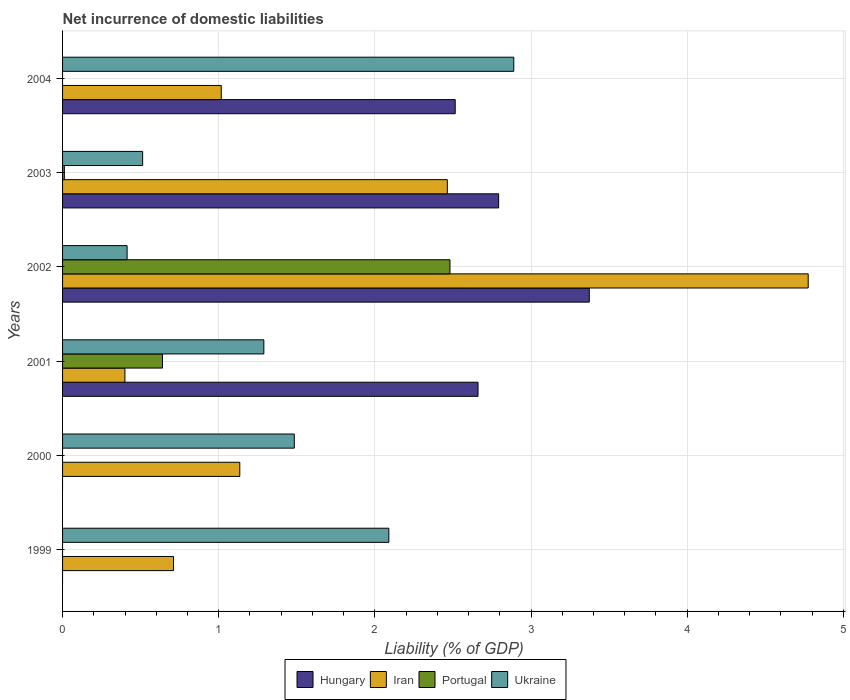How many bars are there on the 1st tick from the bottom?
Offer a terse response. 2. What is the label of the 4th group of bars from the top?
Provide a short and direct response. 2001. What is the net incurrence of domestic liabilities in Ukraine in 2001?
Ensure brevity in your answer.  1.29. Across all years, what is the maximum net incurrence of domestic liabilities in Portugal?
Your answer should be very brief. 2.48. Across all years, what is the minimum net incurrence of domestic liabilities in Ukraine?
Offer a very short reply. 0.41. In which year was the net incurrence of domestic liabilities in Iran maximum?
Ensure brevity in your answer.  2002. What is the total net incurrence of domestic liabilities in Portugal in the graph?
Provide a short and direct response. 3.13. What is the difference between the net incurrence of domestic liabilities in Iran in 2002 and that in 2003?
Provide a succinct answer. 2.31. What is the difference between the net incurrence of domestic liabilities in Hungary in 2001 and the net incurrence of domestic liabilities in Portugal in 2003?
Give a very brief answer. 2.65. What is the average net incurrence of domestic liabilities in Portugal per year?
Your response must be concise. 0.52. In the year 2002, what is the difference between the net incurrence of domestic liabilities in Portugal and net incurrence of domestic liabilities in Iran?
Provide a short and direct response. -2.29. What is the ratio of the net incurrence of domestic liabilities in Portugal in 2002 to that in 2003?
Offer a very short reply. 215.32. Is the net incurrence of domestic liabilities in Iran in 1999 less than that in 2002?
Your answer should be very brief. Yes. Is the difference between the net incurrence of domestic liabilities in Portugal in 2001 and 2002 greater than the difference between the net incurrence of domestic liabilities in Iran in 2001 and 2002?
Your answer should be very brief. Yes. What is the difference between the highest and the second highest net incurrence of domestic liabilities in Portugal?
Offer a very short reply. 1.84. What is the difference between the highest and the lowest net incurrence of domestic liabilities in Ukraine?
Provide a short and direct response. 2.48. Is it the case that in every year, the sum of the net incurrence of domestic liabilities in Hungary and net incurrence of domestic liabilities in Iran is greater than the sum of net incurrence of domestic liabilities in Ukraine and net incurrence of domestic liabilities in Portugal?
Your answer should be very brief. No. Is it the case that in every year, the sum of the net incurrence of domestic liabilities in Iran and net incurrence of domestic liabilities in Portugal is greater than the net incurrence of domestic liabilities in Ukraine?
Provide a succinct answer. No. Are the values on the major ticks of X-axis written in scientific E-notation?
Your answer should be very brief. No. Does the graph contain any zero values?
Give a very brief answer. Yes. Where does the legend appear in the graph?
Ensure brevity in your answer.  Bottom center. How many legend labels are there?
Make the answer very short. 4. What is the title of the graph?
Offer a terse response. Net incurrence of domestic liabilities. What is the label or title of the X-axis?
Keep it short and to the point. Liability (% of GDP). What is the Liability (% of GDP) of Hungary in 1999?
Your answer should be very brief. 0. What is the Liability (% of GDP) of Iran in 1999?
Give a very brief answer. 0.71. What is the Liability (% of GDP) of Portugal in 1999?
Ensure brevity in your answer.  0. What is the Liability (% of GDP) of Ukraine in 1999?
Keep it short and to the point. 2.09. What is the Liability (% of GDP) of Hungary in 2000?
Make the answer very short. 0. What is the Liability (% of GDP) in Iran in 2000?
Give a very brief answer. 1.13. What is the Liability (% of GDP) of Portugal in 2000?
Provide a short and direct response. 0. What is the Liability (% of GDP) of Ukraine in 2000?
Your response must be concise. 1.48. What is the Liability (% of GDP) in Hungary in 2001?
Your answer should be compact. 2.66. What is the Liability (% of GDP) in Iran in 2001?
Make the answer very short. 0.4. What is the Liability (% of GDP) in Portugal in 2001?
Provide a succinct answer. 0.64. What is the Liability (% of GDP) in Ukraine in 2001?
Make the answer very short. 1.29. What is the Liability (% of GDP) of Hungary in 2002?
Give a very brief answer. 3.37. What is the Liability (% of GDP) in Iran in 2002?
Your answer should be compact. 4.78. What is the Liability (% of GDP) of Portugal in 2002?
Give a very brief answer. 2.48. What is the Liability (% of GDP) in Ukraine in 2002?
Ensure brevity in your answer.  0.41. What is the Liability (% of GDP) of Hungary in 2003?
Provide a short and direct response. 2.79. What is the Liability (% of GDP) in Iran in 2003?
Offer a terse response. 2.46. What is the Liability (% of GDP) of Portugal in 2003?
Provide a short and direct response. 0.01. What is the Liability (% of GDP) in Ukraine in 2003?
Provide a succinct answer. 0.51. What is the Liability (% of GDP) of Hungary in 2004?
Ensure brevity in your answer.  2.51. What is the Liability (% of GDP) in Iran in 2004?
Provide a short and direct response. 1.02. What is the Liability (% of GDP) of Portugal in 2004?
Keep it short and to the point. 0. What is the Liability (% of GDP) of Ukraine in 2004?
Your response must be concise. 2.89. Across all years, what is the maximum Liability (% of GDP) of Hungary?
Your answer should be compact. 3.37. Across all years, what is the maximum Liability (% of GDP) in Iran?
Your answer should be very brief. 4.78. Across all years, what is the maximum Liability (% of GDP) of Portugal?
Your answer should be very brief. 2.48. Across all years, what is the maximum Liability (% of GDP) in Ukraine?
Give a very brief answer. 2.89. Across all years, what is the minimum Liability (% of GDP) of Iran?
Offer a terse response. 0.4. Across all years, what is the minimum Liability (% of GDP) of Ukraine?
Offer a very short reply. 0.41. What is the total Liability (% of GDP) in Hungary in the graph?
Your answer should be compact. 11.34. What is the total Liability (% of GDP) in Iran in the graph?
Offer a very short reply. 10.5. What is the total Liability (% of GDP) of Portugal in the graph?
Provide a short and direct response. 3.13. What is the total Liability (% of GDP) in Ukraine in the graph?
Offer a very short reply. 8.68. What is the difference between the Liability (% of GDP) in Iran in 1999 and that in 2000?
Provide a succinct answer. -0.42. What is the difference between the Liability (% of GDP) of Ukraine in 1999 and that in 2000?
Your answer should be very brief. 0.61. What is the difference between the Liability (% of GDP) in Iran in 1999 and that in 2001?
Ensure brevity in your answer.  0.31. What is the difference between the Liability (% of GDP) in Ukraine in 1999 and that in 2001?
Offer a very short reply. 0.8. What is the difference between the Liability (% of GDP) of Iran in 1999 and that in 2002?
Offer a terse response. -4.06. What is the difference between the Liability (% of GDP) of Ukraine in 1999 and that in 2002?
Your answer should be very brief. 1.68. What is the difference between the Liability (% of GDP) in Iran in 1999 and that in 2003?
Make the answer very short. -1.75. What is the difference between the Liability (% of GDP) of Ukraine in 1999 and that in 2003?
Make the answer very short. 1.58. What is the difference between the Liability (% of GDP) in Iran in 1999 and that in 2004?
Offer a terse response. -0.31. What is the difference between the Liability (% of GDP) of Iran in 2000 and that in 2001?
Keep it short and to the point. 0.74. What is the difference between the Liability (% of GDP) of Ukraine in 2000 and that in 2001?
Keep it short and to the point. 0.2. What is the difference between the Liability (% of GDP) of Iran in 2000 and that in 2002?
Provide a succinct answer. -3.64. What is the difference between the Liability (% of GDP) of Ukraine in 2000 and that in 2002?
Your answer should be compact. 1.07. What is the difference between the Liability (% of GDP) in Iran in 2000 and that in 2003?
Provide a short and direct response. -1.33. What is the difference between the Liability (% of GDP) of Ukraine in 2000 and that in 2003?
Offer a terse response. 0.97. What is the difference between the Liability (% of GDP) in Iran in 2000 and that in 2004?
Make the answer very short. 0.12. What is the difference between the Liability (% of GDP) of Ukraine in 2000 and that in 2004?
Offer a very short reply. -1.41. What is the difference between the Liability (% of GDP) of Hungary in 2001 and that in 2002?
Provide a short and direct response. -0.71. What is the difference between the Liability (% of GDP) of Iran in 2001 and that in 2002?
Your answer should be compact. -4.38. What is the difference between the Liability (% of GDP) of Portugal in 2001 and that in 2002?
Your answer should be compact. -1.84. What is the difference between the Liability (% of GDP) in Ukraine in 2001 and that in 2002?
Ensure brevity in your answer.  0.88. What is the difference between the Liability (% of GDP) in Hungary in 2001 and that in 2003?
Provide a short and direct response. -0.13. What is the difference between the Liability (% of GDP) of Iran in 2001 and that in 2003?
Offer a terse response. -2.06. What is the difference between the Liability (% of GDP) in Portugal in 2001 and that in 2003?
Your answer should be very brief. 0.63. What is the difference between the Liability (% of GDP) of Ukraine in 2001 and that in 2003?
Your response must be concise. 0.78. What is the difference between the Liability (% of GDP) of Hungary in 2001 and that in 2004?
Provide a succinct answer. 0.15. What is the difference between the Liability (% of GDP) of Iran in 2001 and that in 2004?
Your response must be concise. -0.62. What is the difference between the Liability (% of GDP) in Ukraine in 2001 and that in 2004?
Offer a very short reply. -1.6. What is the difference between the Liability (% of GDP) of Hungary in 2002 and that in 2003?
Offer a terse response. 0.58. What is the difference between the Liability (% of GDP) of Iran in 2002 and that in 2003?
Your answer should be compact. 2.31. What is the difference between the Liability (% of GDP) in Portugal in 2002 and that in 2003?
Keep it short and to the point. 2.47. What is the difference between the Liability (% of GDP) in Ukraine in 2002 and that in 2003?
Make the answer very short. -0.1. What is the difference between the Liability (% of GDP) of Hungary in 2002 and that in 2004?
Give a very brief answer. 0.86. What is the difference between the Liability (% of GDP) in Iran in 2002 and that in 2004?
Offer a very short reply. 3.76. What is the difference between the Liability (% of GDP) of Ukraine in 2002 and that in 2004?
Your response must be concise. -2.48. What is the difference between the Liability (% of GDP) in Hungary in 2003 and that in 2004?
Ensure brevity in your answer.  0.28. What is the difference between the Liability (% of GDP) of Iran in 2003 and that in 2004?
Ensure brevity in your answer.  1.45. What is the difference between the Liability (% of GDP) of Ukraine in 2003 and that in 2004?
Offer a terse response. -2.38. What is the difference between the Liability (% of GDP) in Iran in 1999 and the Liability (% of GDP) in Ukraine in 2000?
Provide a short and direct response. -0.77. What is the difference between the Liability (% of GDP) in Iran in 1999 and the Liability (% of GDP) in Portugal in 2001?
Your answer should be compact. 0.07. What is the difference between the Liability (% of GDP) of Iran in 1999 and the Liability (% of GDP) of Ukraine in 2001?
Give a very brief answer. -0.58. What is the difference between the Liability (% of GDP) in Iran in 1999 and the Liability (% of GDP) in Portugal in 2002?
Give a very brief answer. -1.77. What is the difference between the Liability (% of GDP) of Iran in 1999 and the Liability (% of GDP) of Ukraine in 2002?
Provide a short and direct response. 0.3. What is the difference between the Liability (% of GDP) in Iran in 1999 and the Liability (% of GDP) in Portugal in 2003?
Provide a short and direct response. 0.7. What is the difference between the Liability (% of GDP) in Iran in 1999 and the Liability (% of GDP) in Ukraine in 2003?
Your answer should be compact. 0.2. What is the difference between the Liability (% of GDP) of Iran in 1999 and the Liability (% of GDP) of Ukraine in 2004?
Your response must be concise. -2.18. What is the difference between the Liability (% of GDP) in Iran in 2000 and the Liability (% of GDP) in Portugal in 2001?
Give a very brief answer. 0.5. What is the difference between the Liability (% of GDP) of Iran in 2000 and the Liability (% of GDP) of Ukraine in 2001?
Provide a short and direct response. -0.15. What is the difference between the Liability (% of GDP) of Iran in 2000 and the Liability (% of GDP) of Portugal in 2002?
Ensure brevity in your answer.  -1.35. What is the difference between the Liability (% of GDP) of Iran in 2000 and the Liability (% of GDP) of Ukraine in 2002?
Make the answer very short. 0.72. What is the difference between the Liability (% of GDP) of Iran in 2000 and the Liability (% of GDP) of Portugal in 2003?
Give a very brief answer. 1.12. What is the difference between the Liability (% of GDP) in Iran in 2000 and the Liability (% of GDP) in Ukraine in 2003?
Your response must be concise. 0.62. What is the difference between the Liability (% of GDP) in Iran in 2000 and the Liability (% of GDP) in Ukraine in 2004?
Ensure brevity in your answer.  -1.75. What is the difference between the Liability (% of GDP) of Hungary in 2001 and the Liability (% of GDP) of Iran in 2002?
Your answer should be very brief. -2.11. What is the difference between the Liability (% of GDP) of Hungary in 2001 and the Liability (% of GDP) of Portugal in 2002?
Give a very brief answer. 0.18. What is the difference between the Liability (% of GDP) of Hungary in 2001 and the Liability (% of GDP) of Ukraine in 2002?
Ensure brevity in your answer.  2.25. What is the difference between the Liability (% of GDP) of Iran in 2001 and the Liability (% of GDP) of Portugal in 2002?
Provide a succinct answer. -2.08. What is the difference between the Liability (% of GDP) in Iran in 2001 and the Liability (% of GDP) in Ukraine in 2002?
Provide a succinct answer. -0.01. What is the difference between the Liability (% of GDP) of Portugal in 2001 and the Liability (% of GDP) of Ukraine in 2002?
Offer a very short reply. 0.23. What is the difference between the Liability (% of GDP) in Hungary in 2001 and the Liability (% of GDP) in Iran in 2003?
Your response must be concise. 0.2. What is the difference between the Liability (% of GDP) in Hungary in 2001 and the Liability (% of GDP) in Portugal in 2003?
Give a very brief answer. 2.65. What is the difference between the Liability (% of GDP) of Hungary in 2001 and the Liability (% of GDP) of Ukraine in 2003?
Your answer should be compact. 2.15. What is the difference between the Liability (% of GDP) in Iran in 2001 and the Liability (% of GDP) in Portugal in 2003?
Give a very brief answer. 0.39. What is the difference between the Liability (% of GDP) in Iran in 2001 and the Liability (% of GDP) in Ukraine in 2003?
Ensure brevity in your answer.  -0.11. What is the difference between the Liability (% of GDP) of Portugal in 2001 and the Liability (% of GDP) of Ukraine in 2003?
Offer a very short reply. 0.13. What is the difference between the Liability (% of GDP) in Hungary in 2001 and the Liability (% of GDP) in Iran in 2004?
Your response must be concise. 1.64. What is the difference between the Liability (% of GDP) in Hungary in 2001 and the Liability (% of GDP) in Ukraine in 2004?
Give a very brief answer. -0.23. What is the difference between the Liability (% of GDP) of Iran in 2001 and the Liability (% of GDP) of Ukraine in 2004?
Offer a very short reply. -2.49. What is the difference between the Liability (% of GDP) in Portugal in 2001 and the Liability (% of GDP) in Ukraine in 2004?
Your response must be concise. -2.25. What is the difference between the Liability (% of GDP) in Hungary in 2002 and the Liability (% of GDP) in Iran in 2003?
Give a very brief answer. 0.91. What is the difference between the Liability (% of GDP) in Hungary in 2002 and the Liability (% of GDP) in Portugal in 2003?
Your answer should be very brief. 3.36. What is the difference between the Liability (% of GDP) in Hungary in 2002 and the Liability (% of GDP) in Ukraine in 2003?
Your answer should be compact. 2.86. What is the difference between the Liability (% of GDP) in Iran in 2002 and the Liability (% of GDP) in Portugal in 2003?
Provide a short and direct response. 4.76. What is the difference between the Liability (% of GDP) in Iran in 2002 and the Liability (% of GDP) in Ukraine in 2003?
Your answer should be compact. 4.26. What is the difference between the Liability (% of GDP) of Portugal in 2002 and the Liability (% of GDP) of Ukraine in 2003?
Ensure brevity in your answer.  1.97. What is the difference between the Liability (% of GDP) in Hungary in 2002 and the Liability (% of GDP) in Iran in 2004?
Make the answer very short. 2.36. What is the difference between the Liability (% of GDP) in Hungary in 2002 and the Liability (% of GDP) in Ukraine in 2004?
Offer a terse response. 0.48. What is the difference between the Liability (% of GDP) of Iran in 2002 and the Liability (% of GDP) of Ukraine in 2004?
Keep it short and to the point. 1.89. What is the difference between the Liability (% of GDP) in Portugal in 2002 and the Liability (% of GDP) in Ukraine in 2004?
Make the answer very short. -0.41. What is the difference between the Liability (% of GDP) in Hungary in 2003 and the Liability (% of GDP) in Iran in 2004?
Offer a very short reply. 1.78. What is the difference between the Liability (% of GDP) of Hungary in 2003 and the Liability (% of GDP) of Ukraine in 2004?
Provide a succinct answer. -0.1. What is the difference between the Liability (% of GDP) of Iran in 2003 and the Liability (% of GDP) of Ukraine in 2004?
Your answer should be compact. -0.43. What is the difference between the Liability (% of GDP) in Portugal in 2003 and the Liability (% of GDP) in Ukraine in 2004?
Give a very brief answer. -2.88. What is the average Liability (% of GDP) of Hungary per year?
Give a very brief answer. 1.89. What is the average Liability (% of GDP) of Portugal per year?
Give a very brief answer. 0.52. What is the average Liability (% of GDP) of Ukraine per year?
Ensure brevity in your answer.  1.45. In the year 1999, what is the difference between the Liability (% of GDP) in Iran and Liability (% of GDP) in Ukraine?
Provide a short and direct response. -1.38. In the year 2000, what is the difference between the Liability (% of GDP) of Iran and Liability (% of GDP) of Ukraine?
Ensure brevity in your answer.  -0.35. In the year 2001, what is the difference between the Liability (% of GDP) in Hungary and Liability (% of GDP) in Iran?
Provide a succinct answer. 2.26. In the year 2001, what is the difference between the Liability (% of GDP) of Hungary and Liability (% of GDP) of Portugal?
Provide a succinct answer. 2.02. In the year 2001, what is the difference between the Liability (% of GDP) in Hungary and Liability (% of GDP) in Ukraine?
Offer a very short reply. 1.37. In the year 2001, what is the difference between the Liability (% of GDP) in Iran and Liability (% of GDP) in Portugal?
Provide a succinct answer. -0.24. In the year 2001, what is the difference between the Liability (% of GDP) of Iran and Liability (% of GDP) of Ukraine?
Provide a succinct answer. -0.89. In the year 2001, what is the difference between the Liability (% of GDP) of Portugal and Liability (% of GDP) of Ukraine?
Offer a very short reply. -0.65. In the year 2002, what is the difference between the Liability (% of GDP) in Hungary and Liability (% of GDP) in Iran?
Your response must be concise. -1.4. In the year 2002, what is the difference between the Liability (% of GDP) in Hungary and Liability (% of GDP) in Portugal?
Offer a terse response. 0.89. In the year 2002, what is the difference between the Liability (% of GDP) of Hungary and Liability (% of GDP) of Ukraine?
Provide a short and direct response. 2.96. In the year 2002, what is the difference between the Liability (% of GDP) in Iran and Liability (% of GDP) in Portugal?
Make the answer very short. 2.29. In the year 2002, what is the difference between the Liability (% of GDP) in Iran and Liability (% of GDP) in Ukraine?
Your answer should be compact. 4.36. In the year 2002, what is the difference between the Liability (% of GDP) of Portugal and Liability (% of GDP) of Ukraine?
Provide a succinct answer. 2.07. In the year 2003, what is the difference between the Liability (% of GDP) of Hungary and Liability (% of GDP) of Iran?
Your response must be concise. 0.33. In the year 2003, what is the difference between the Liability (% of GDP) of Hungary and Liability (% of GDP) of Portugal?
Provide a short and direct response. 2.78. In the year 2003, what is the difference between the Liability (% of GDP) of Hungary and Liability (% of GDP) of Ukraine?
Keep it short and to the point. 2.28. In the year 2003, what is the difference between the Liability (% of GDP) of Iran and Liability (% of GDP) of Portugal?
Give a very brief answer. 2.45. In the year 2003, what is the difference between the Liability (% of GDP) in Iran and Liability (% of GDP) in Ukraine?
Give a very brief answer. 1.95. In the year 2003, what is the difference between the Liability (% of GDP) of Portugal and Liability (% of GDP) of Ukraine?
Provide a short and direct response. -0.5. In the year 2004, what is the difference between the Liability (% of GDP) of Hungary and Liability (% of GDP) of Iran?
Offer a very short reply. 1.5. In the year 2004, what is the difference between the Liability (% of GDP) in Hungary and Liability (% of GDP) in Ukraine?
Offer a terse response. -0.38. In the year 2004, what is the difference between the Liability (% of GDP) of Iran and Liability (% of GDP) of Ukraine?
Offer a very short reply. -1.87. What is the ratio of the Liability (% of GDP) in Iran in 1999 to that in 2000?
Ensure brevity in your answer.  0.63. What is the ratio of the Liability (% of GDP) of Ukraine in 1999 to that in 2000?
Give a very brief answer. 1.41. What is the ratio of the Liability (% of GDP) in Iran in 1999 to that in 2001?
Provide a succinct answer. 1.78. What is the ratio of the Liability (% of GDP) of Ukraine in 1999 to that in 2001?
Make the answer very short. 1.62. What is the ratio of the Liability (% of GDP) of Iran in 1999 to that in 2002?
Offer a terse response. 0.15. What is the ratio of the Liability (% of GDP) of Ukraine in 1999 to that in 2002?
Make the answer very short. 5.06. What is the ratio of the Liability (% of GDP) in Iran in 1999 to that in 2003?
Give a very brief answer. 0.29. What is the ratio of the Liability (% of GDP) in Ukraine in 1999 to that in 2003?
Give a very brief answer. 4.08. What is the ratio of the Liability (% of GDP) in Iran in 1999 to that in 2004?
Make the answer very short. 0.7. What is the ratio of the Liability (% of GDP) of Ukraine in 1999 to that in 2004?
Your response must be concise. 0.72. What is the ratio of the Liability (% of GDP) in Iran in 2000 to that in 2001?
Ensure brevity in your answer.  2.84. What is the ratio of the Liability (% of GDP) of Ukraine in 2000 to that in 2001?
Provide a succinct answer. 1.15. What is the ratio of the Liability (% of GDP) of Iran in 2000 to that in 2002?
Make the answer very short. 0.24. What is the ratio of the Liability (% of GDP) of Ukraine in 2000 to that in 2002?
Your answer should be very brief. 3.59. What is the ratio of the Liability (% of GDP) of Iran in 2000 to that in 2003?
Your answer should be compact. 0.46. What is the ratio of the Liability (% of GDP) of Ukraine in 2000 to that in 2003?
Your answer should be compact. 2.89. What is the ratio of the Liability (% of GDP) in Iran in 2000 to that in 2004?
Offer a very short reply. 1.12. What is the ratio of the Liability (% of GDP) of Ukraine in 2000 to that in 2004?
Offer a very short reply. 0.51. What is the ratio of the Liability (% of GDP) in Hungary in 2001 to that in 2002?
Ensure brevity in your answer.  0.79. What is the ratio of the Liability (% of GDP) in Iran in 2001 to that in 2002?
Offer a terse response. 0.08. What is the ratio of the Liability (% of GDP) of Portugal in 2001 to that in 2002?
Your answer should be very brief. 0.26. What is the ratio of the Liability (% of GDP) of Ukraine in 2001 to that in 2002?
Your answer should be very brief. 3.12. What is the ratio of the Liability (% of GDP) in Hungary in 2001 to that in 2003?
Keep it short and to the point. 0.95. What is the ratio of the Liability (% of GDP) in Iran in 2001 to that in 2003?
Your response must be concise. 0.16. What is the ratio of the Liability (% of GDP) in Portugal in 2001 to that in 2003?
Provide a short and direct response. 55.52. What is the ratio of the Liability (% of GDP) of Ukraine in 2001 to that in 2003?
Provide a succinct answer. 2.51. What is the ratio of the Liability (% of GDP) of Hungary in 2001 to that in 2004?
Give a very brief answer. 1.06. What is the ratio of the Liability (% of GDP) of Iran in 2001 to that in 2004?
Provide a succinct answer. 0.39. What is the ratio of the Liability (% of GDP) in Ukraine in 2001 to that in 2004?
Offer a very short reply. 0.45. What is the ratio of the Liability (% of GDP) of Hungary in 2002 to that in 2003?
Ensure brevity in your answer.  1.21. What is the ratio of the Liability (% of GDP) in Iran in 2002 to that in 2003?
Offer a terse response. 1.94. What is the ratio of the Liability (% of GDP) of Portugal in 2002 to that in 2003?
Provide a succinct answer. 215.32. What is the ratio of the Liability (% of GDP) of Ukraine in 2002 to that in 2003?
Offer a terse response. 0.81. What is the ratio of the Liability (% of GDP) of Hungary in 2002 to that in 2004?
Provide a short and direct response. 1.34. What is the ratio of the Liability (% of GDP) of Iran in 2002 to that in 2004?
Ensure brevity in your answer.  4.7. What is the ratio of the Liability (% of GDP) in Ukraine in 2002 to that in 2004?
Offer a very short reply. 0.14. What is the ratio of the Liability (% of GDP) of Hungary in 2003 to that in 2004?
Ensure brevity in your answer.  1.11. What is the ratio of the Liability (% of GDP) of Iran in 2003 to that in 2004?
Offer a terse response. 2.42. What is the ratio of the Liability (% of GDP) in Ukraine in 2003 to that in 2004?
Your response must be concise. 0.18. What is the difference between the highest and the second highest Liability (% of GDP) of Hungary?
Ensure brevity in your answer.  0.58. What is the difference between the highest and the second highest Liability (% of GDP) of Iran?
Keep it short and to the point. 2.31. What is the difference between the highest and the second highest Liability (% of GDP) in Portugal?
Give a very brief answer. 1.84. What is the difference between the highest and the lowest Liability (% of GDP) of Hungary?
Give a very brief answer. 3.37. What is the difference between the highest and the lowest Liability (% of GDP) of Iran?
Your answer should be compact. 4.38. What is the difference between the highest and the lowest Liability (% of GDP) of Portugal?
Your answer should be compact. 2.48. What is the difference between the highest and the lowest Liability (% of GDP) in Ukraine?
Keep it short and to the point. 2.48. 